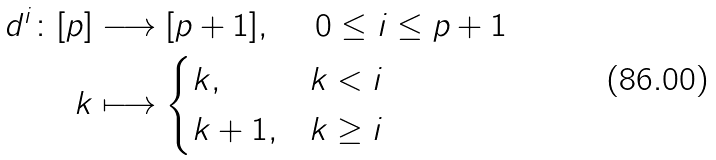Convert formula to latex. <formula><loc_0><loc_0><loc_500><loc_500>d ^ { i } \colon [ p ] & \longrightarrow [ p + 1 ] , \quad \ 0 \leq i \leq p + 1 \\ k & \longmapsto \begin{cases} k , & k < i \\ k + 1 , & k \geq i \end{cases}</formula> 